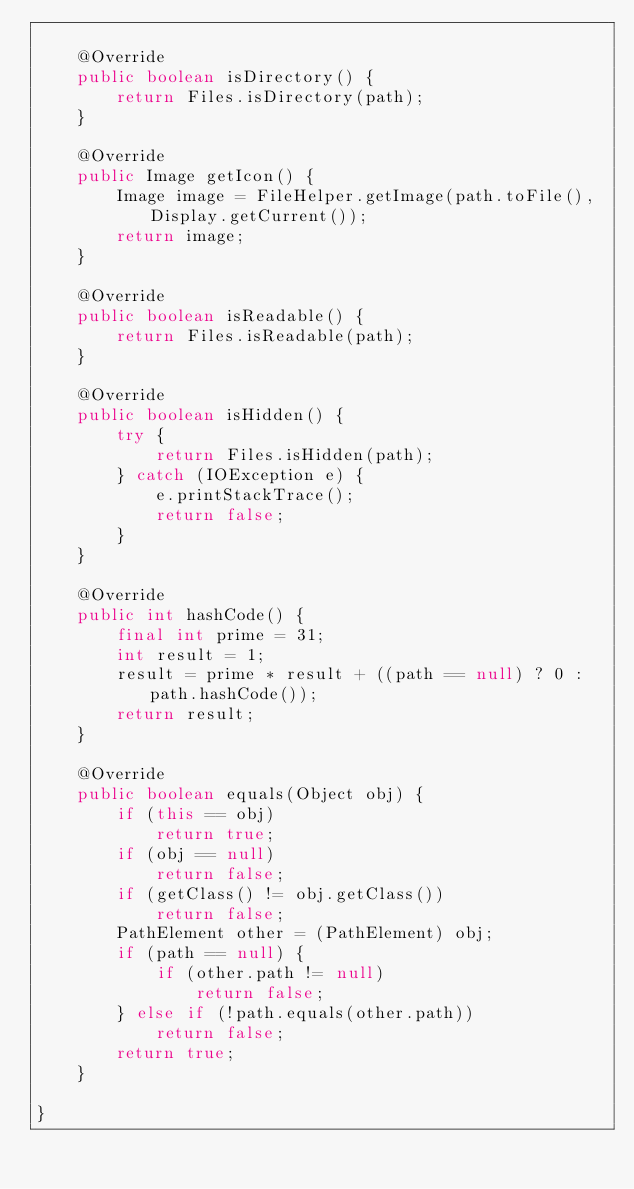<code> <loc_0><loc_0><loc_500><loc_500><_Java_>
	@Override
	public boolean isDirectory() {
		return Files.isDirectory(path);
	}

	@Override
	public Image getIcon() {
		Image image = FileHelper.getImage(path.toFile(), Display.getCurrent());
		return image;
	}

	@Override
	public boolean isReadable() {
		return Files.isReadable(path);
	}

	@Override
	public boolean isHidden() {
		try {
			return Files.isHidden(path);
		} catch (IOException e) {
			e.printStackTrace();
			return false;
		}
	}

	@Override
	public int hashCode() {
		final int prime = 31;
		int result = 1;
		result = prime * result + ((path == null) ? 0 : path.hashCode());
		return result;
	}

	@Override
	public boolean equals(Object obj) {
		if (this == obj)
			return true;
		if (obj == null)
			return false;
		if (getClass() != obj.getClass())
			return false;
		PathElement other = (PathElement) obj;
		if (path == null) {
			if (other.path != null)
				return false;
		} else if (!path.equals(other.path))
			return false;
		return true;
	}
	
}
</code> 